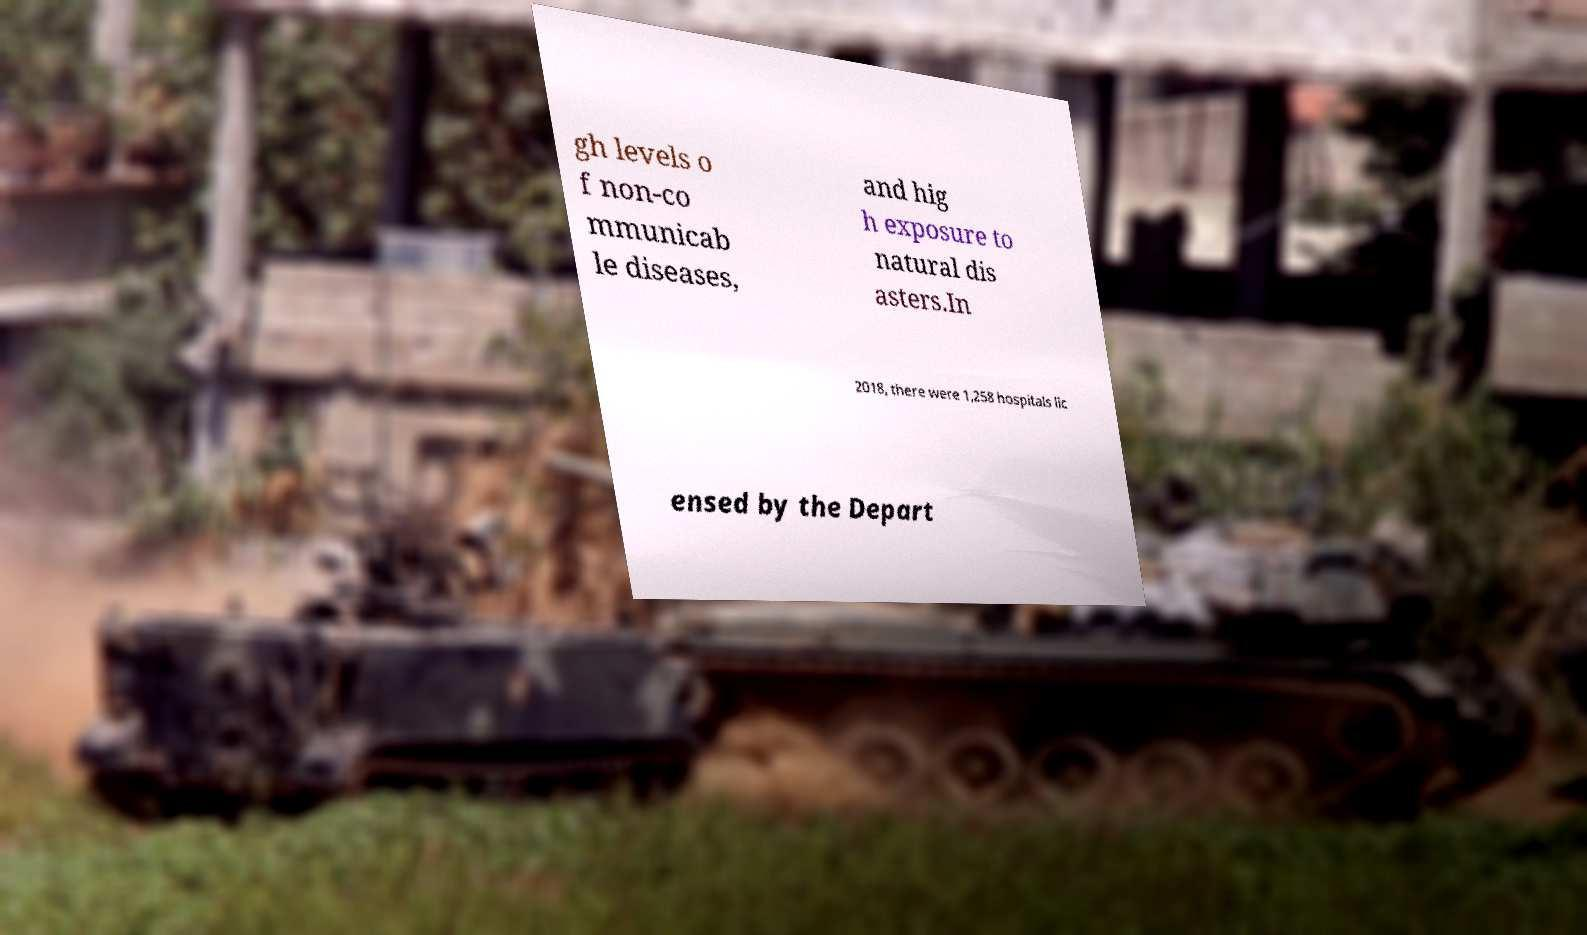Can you read and provide the text displayed in the image?This photo seems to have some interesting text. Can you extract and type it out for me? gh levels o f non-co mmunicab le diseases, and hig h exposure to natural dis asters.In 2018, there were 1,258 hospitals lic ensed by the Depart 